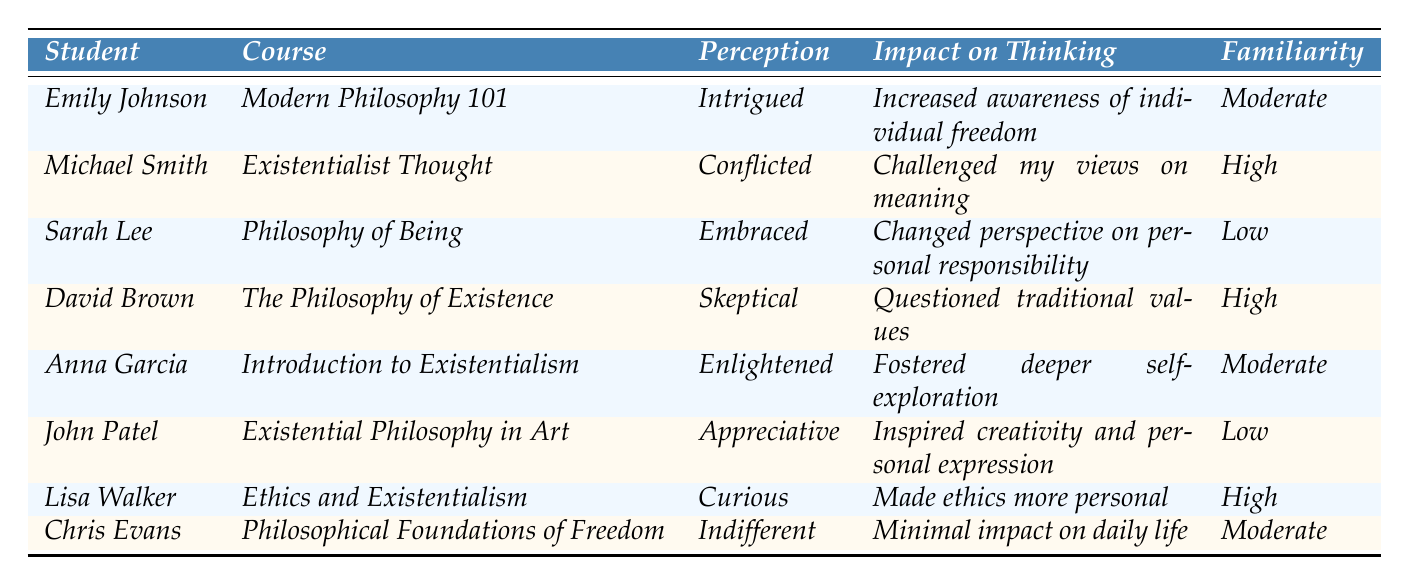What is the perception of Emily Johnson towards existentialism? Emily Johnson's perception of existentialism is listed in the table as "Intrigued." Therefore, the answer is directly obtained from the corresponding row under the "Perception" column for Emily Johnson.
Answer: Intrigued Which course has the highest familiarity with Kierkegaard? The students' familiarity with Kierkegaard is labeled as "High" for the following students: Michael Smith, David Brown, and Lisa Walker, all of whom belong to different courses. The courses are: Existentialist Thought, The Philosophy of Existence, and Ethics and Existentialism. Therefore, there are three courses with high familiarity, and no single course has the highest familiarity.
Answer: There are three courses with high familiarity What is the impact on thinking for students who embraced existentialism? From the table, only Sarah Lee states that they "Embraced" existentialism, which indicates a shift in their perception. The stated impact on thinking for Sarah Lee is that it "Changed perspective on personal responsibility." Hence, we refer to the relevant entry under the "Impact on Thinking" column for Sarah Lee.
Answer: Changed perspective on personal responsibility How many students reported being indifferent towards existentialism? According to the table, there is only one student, Chris Evans, whose perception of existentialism is noted as "Indifferent." Thus, we can directly identify the number of students with this perception based on the provided information.
Answer: One Is there a correlation between familiarity with Kierkegaard and perception of existentialism? Analyzing the perceptions of the students in conjunction with their familiarity reveals that students with high familiarity (such as Michael Smith and David Brown) have conflicting perceptions (Conflicted and Skeptical), while students with low familiarity (e.g., John Patel) express positive perceptions (Appreciative). This suggests there is no clear correlation, just variability in perceptions across different familiarity levels.
Answer: No clear correlation What proportion of students feel positively (Embraced or Appreciative) towards existentialism? The table shows that Sarah Lee (Embraced) and John Patel (Appreciative) are the only two students expressing positive sentiments, lead to a count of 2 out of 8 total students. The proportion is then calculated as (2/8) = 0.25 or 25%.
Answer: 25% Which student expressed a curious viewpoint towards existentialism? The student Lisa Walker is noted in the table as expressing a "Curious" perception of existentialism. We refer to the relevant entry under the "Perception" column.
Answer: Lisa Walker What is the average familiarity level with Kierkegaard among all students? Familiarity levels are given as Moderate (3), High (4), Low (2). To find an average rating: High (3 counts × 4) + Moderate (3 counts × 3) + Low (2 counts × 2), totaling 3×4 + 3×3 + 2×2 = 12 + 9 + 4 = 25, then divide by the number of students (8) to get an average value of 25/8 = 3.125.
Answer: 3.125 